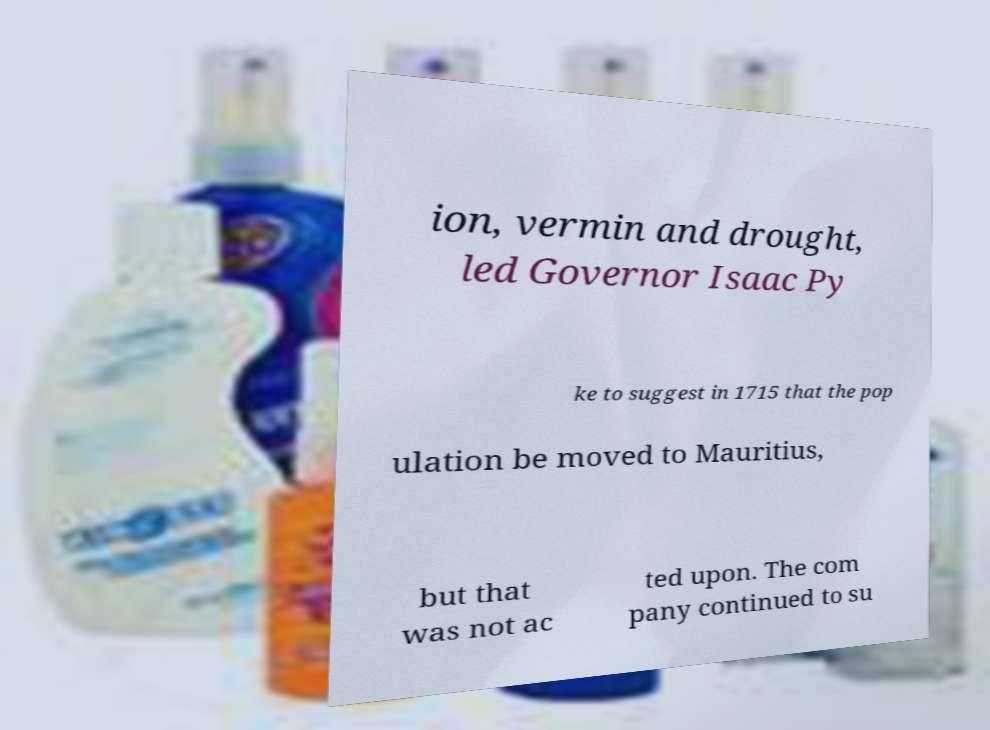Could you assist in decoding the text presented in this image and type it out clearly? ion, vermin and drought, led Governor Isaac Py ke to suggest in 1715 that the pop ulation be moved to Mauritius, but that was not ac ted upon. The com pany continued to su 